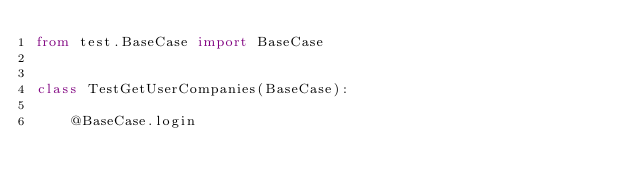<code> <loc_0><loc_0><loc_500><loc_500><_Python_>from test.BaseCase import BaseCase


class TestGetUserCompanies(BaseCase):

    @BaseCase.login</code> 